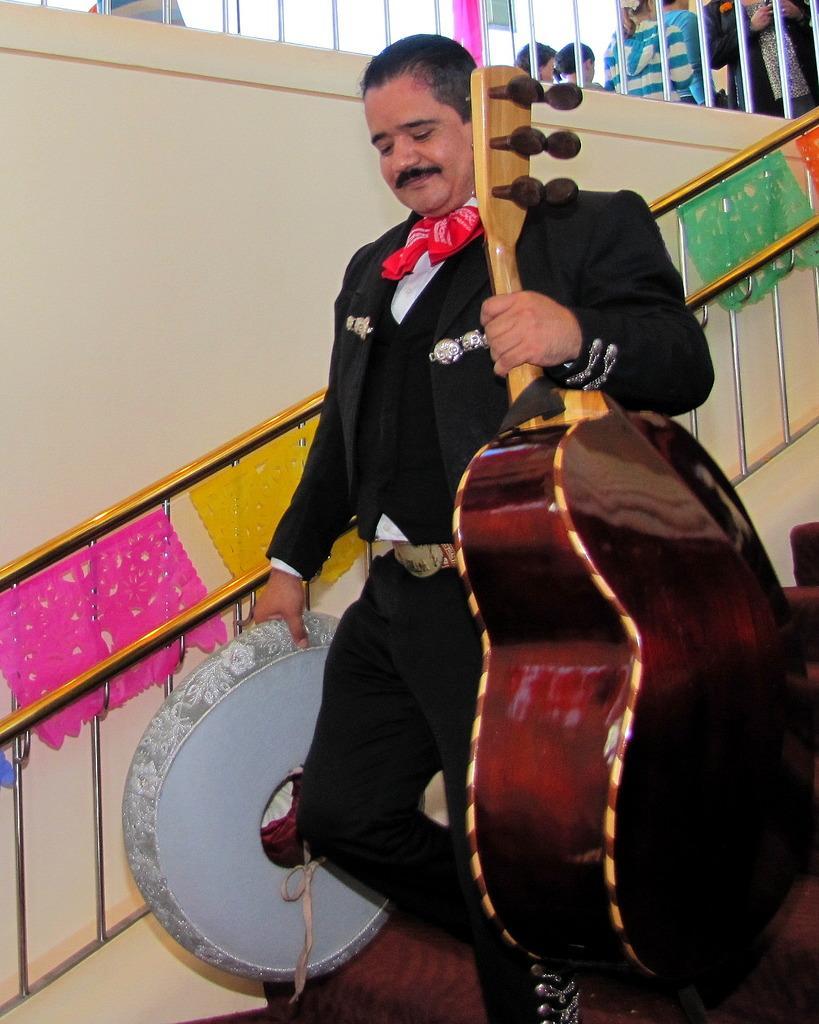Please provide a concise description of this image. In this image there is a man walking, he is holding a guitar and an object, there are staircase, there are group of persons towards the top of the image, there are decorative papers, there is the wall. 